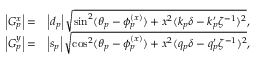Convert formula to latex. <formula><loc_0><loc_0><loc_500><loc_500>\begin{array} { r l } { \left | G _ { p } ^ { x } \right | = } & { \left | d _ { p } \right | \sqrt { \sin ^ { 2 } ( \theta _ { p } - \phi _ { p } ^ { ( x ) } ) + x ^ { 2 } ( k _ { p } \delta - k _ { p } ^ { \prime } \zeta ^ { - 1 } ) ^ { 2 } } , } \\ { \left | G _ { p } ^ { y } \right | = } & { \left | s _ { p } \right | \sqrt { \cos ^ { 2 } ( \theta _ { p } - \phi _ { p } ^ { ( x ) } ) + x ^ { 2 } ( q _ { p } \delta - q _ { p } ^ { \prime } \zeta ^ { - 1 } ) ^ { 2 } } , } \end{array}</formula> 